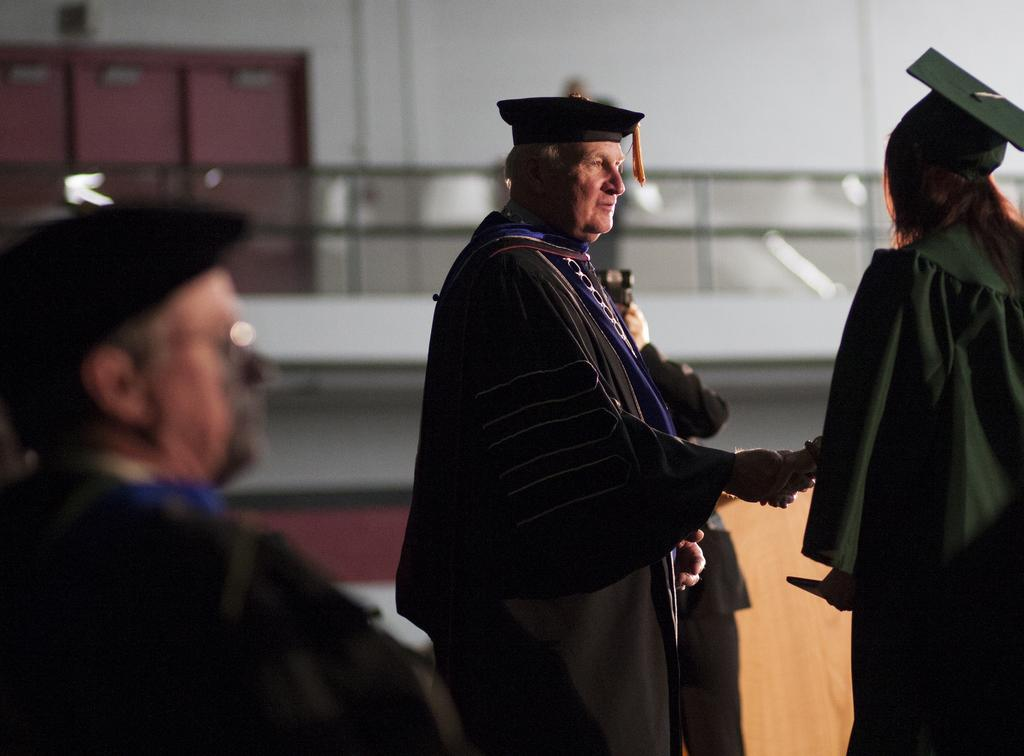How many people are in the image? There are four persons in the image. What are the people in the front wearing? The three persons in the front are wearing hats. What is the person in the background holding? The person in the background is holding a camera. What can be seen in the background of the image? There is a wall in the background of the image. What type of mouth can be seen on the wall in the image? There is no mouth present on the wall in the image. Are the people in the image playing any games or sports? The provided facts do not mention any games or sports being played in the image. 